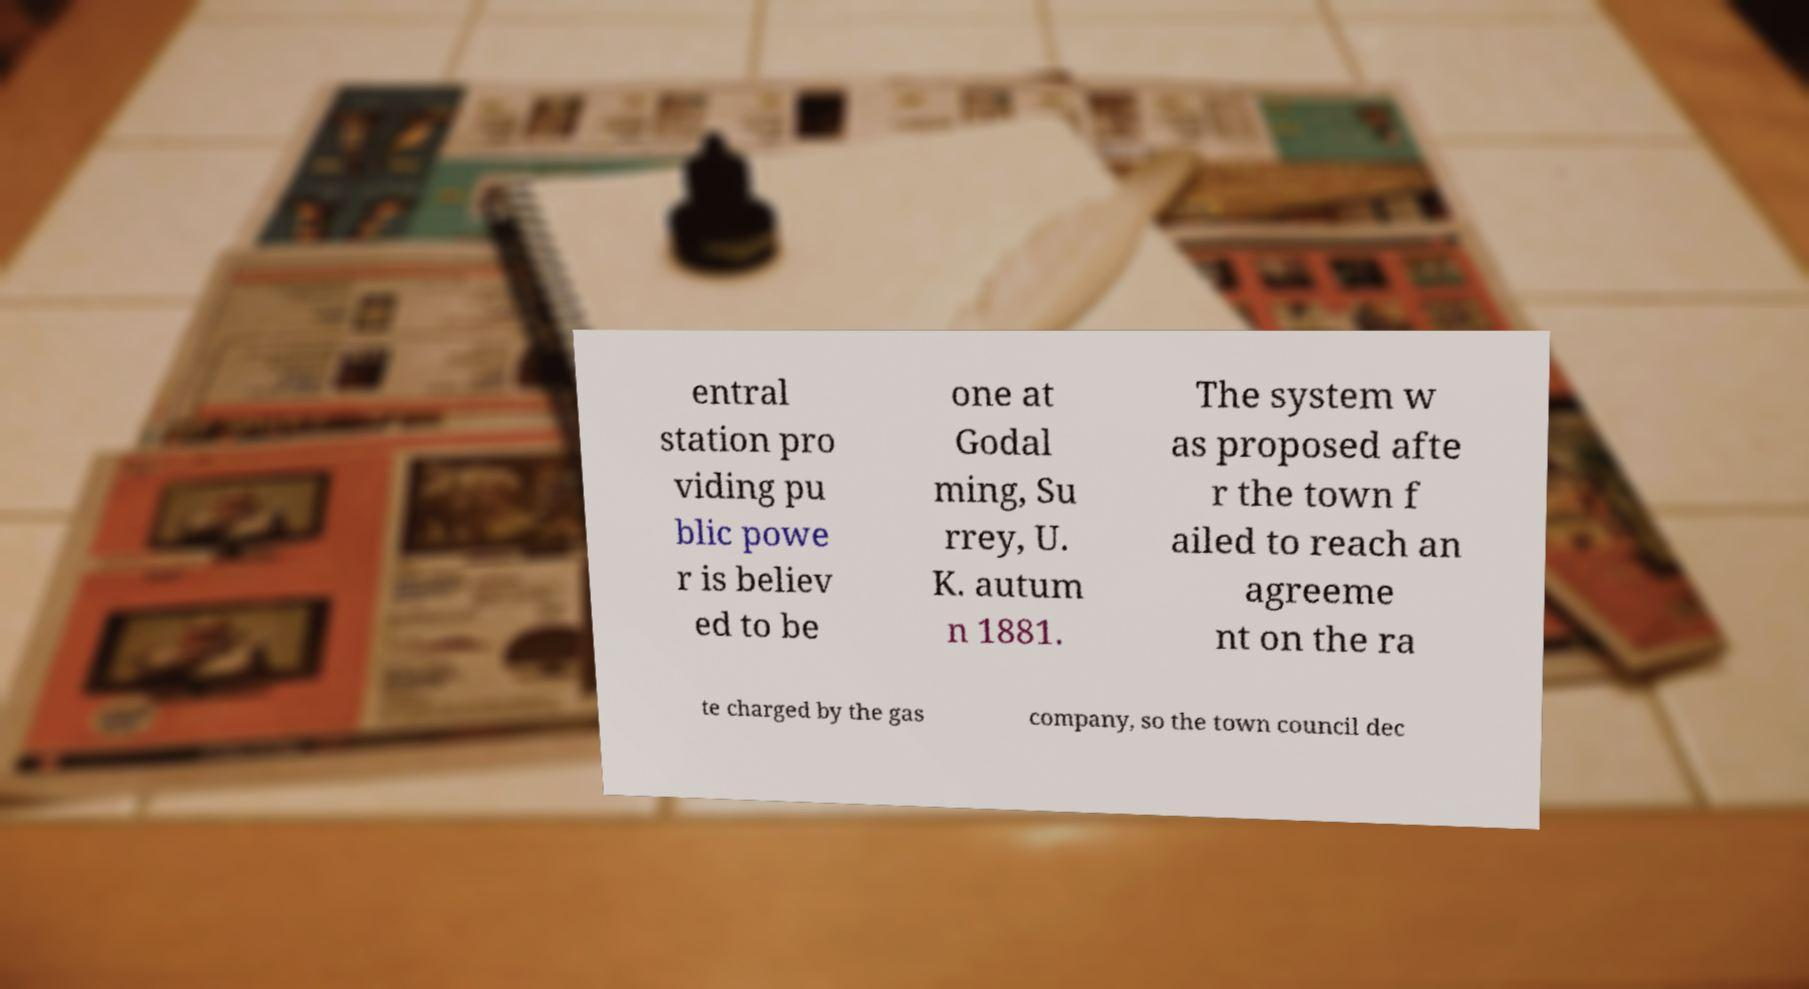Can you accurately transcribe the text from the provided image for me? entral station pro viding pu blic powe r is believ ed to be one at Godal ming, Su rrey, U. K. autum n 1881. The system w as proposed afte r the town f ailed to reach an agreeme nt on the ra te charged by the gas company, so the town council dec 